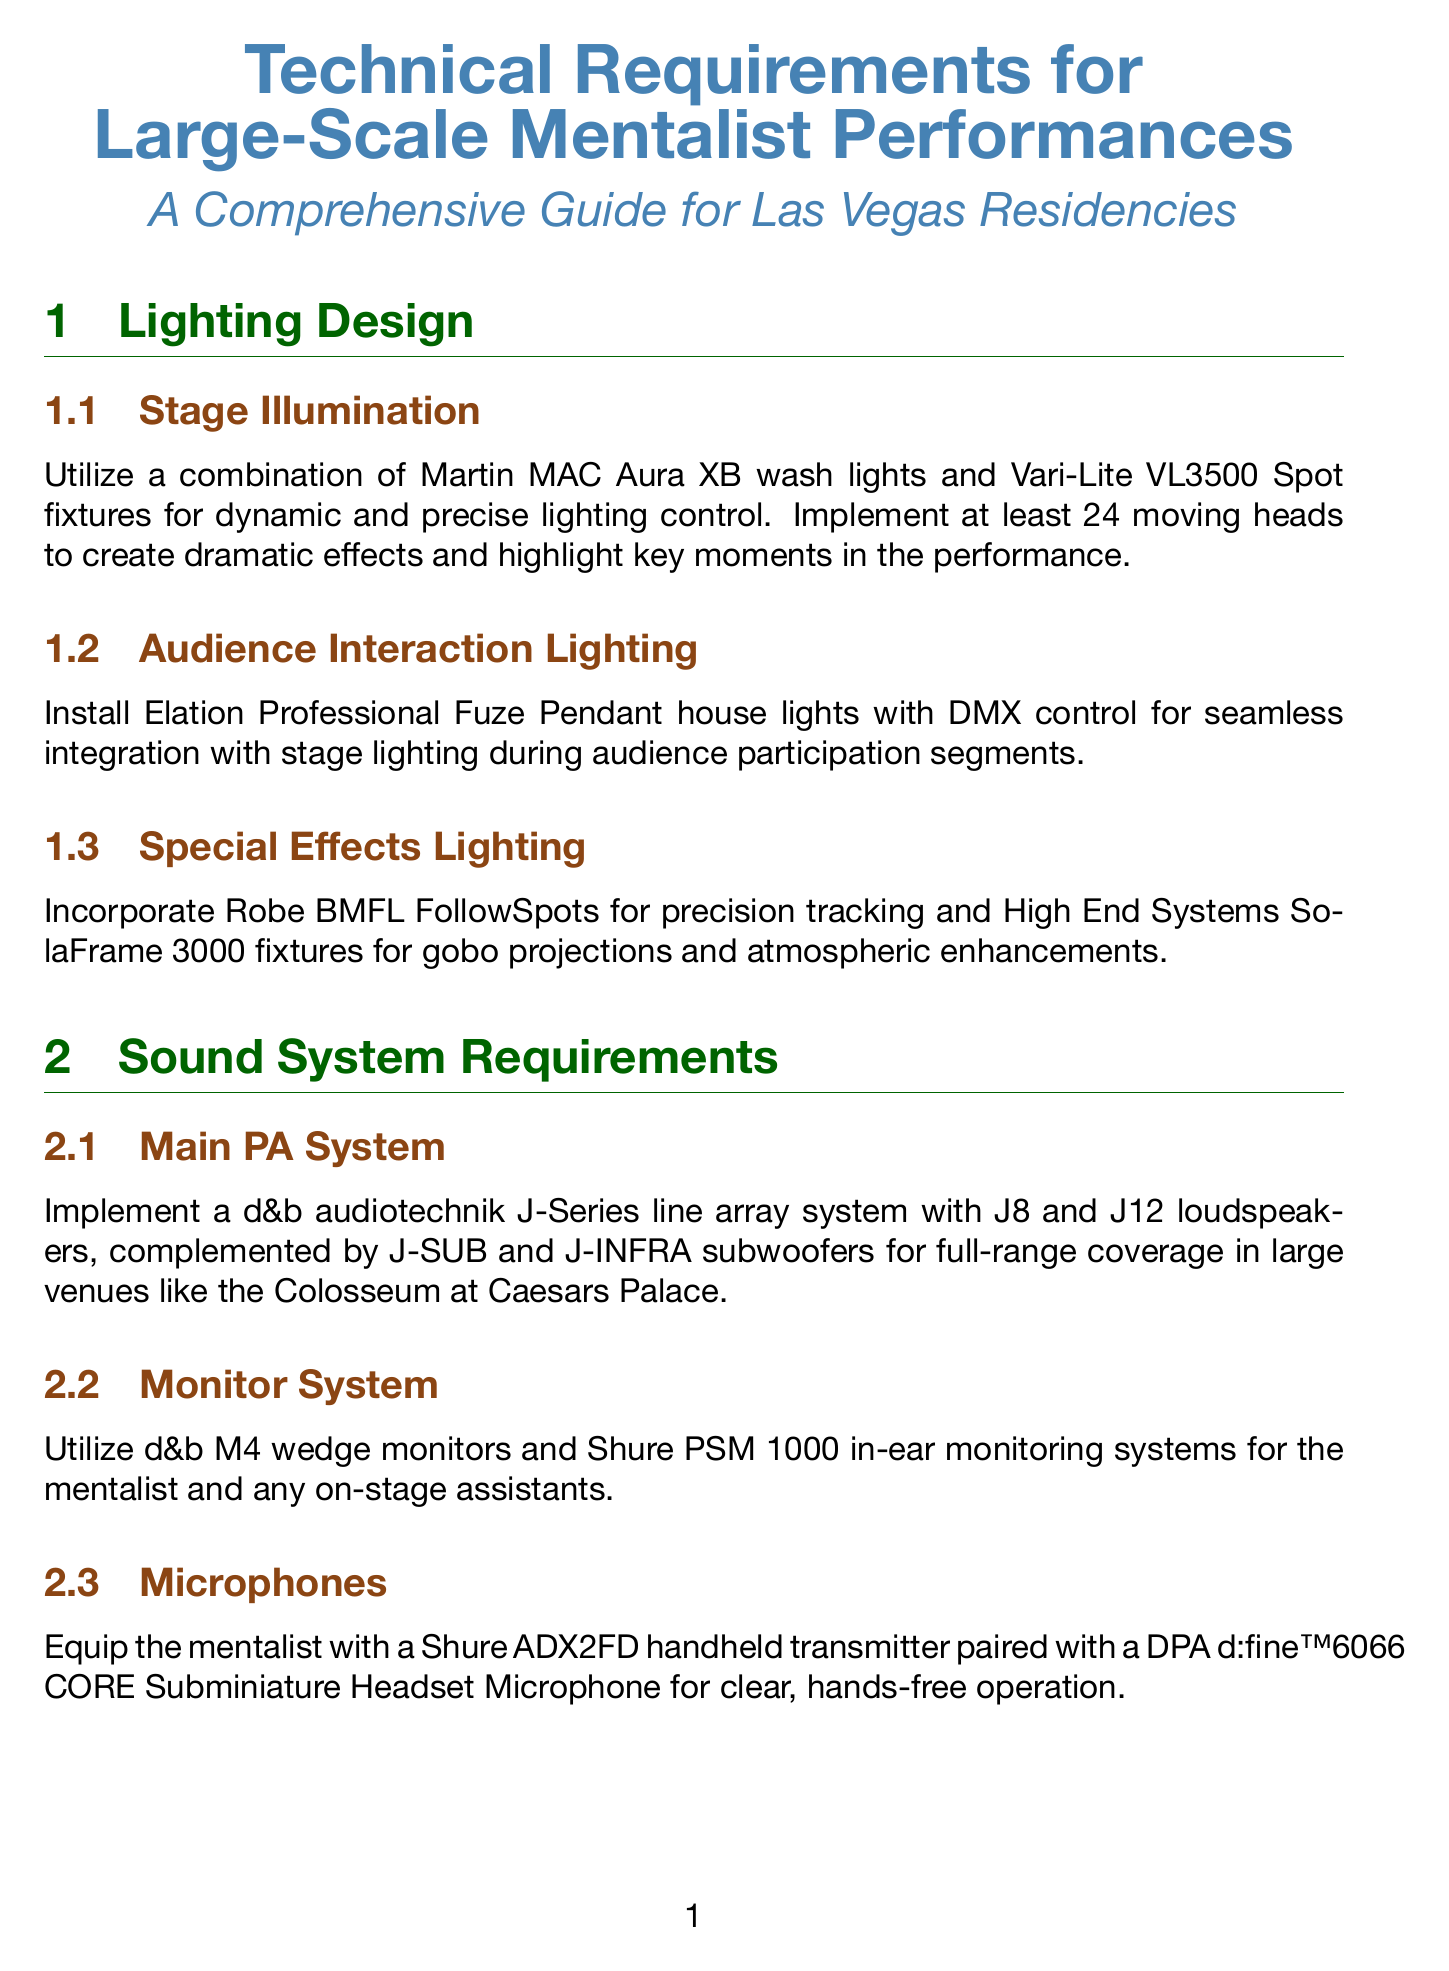What lighting fixtures are recommended for stage illumination? The document specifies using Martin MAC Aura XB wash lights and Vari-Lite VL3500 Spot fixtures for stage illumination.
Answer: Martin MAC Aura XB wash lights and Vari-Lite VL3500 Spot fixtures How many moving heads should be implemented? The manual suggests implementing at least 24 moving heads for dramatic effects.
Answer: 24 What sound system is recommended for large venues? The main PA system recommended is a d&b audiotechnik J-Series line array system.
Answer: d&b audiotechnik J-Series line array system What type of video projection system is suggested? A Barco UDX-4K32 laser projector is suggested for high-resolution backdrop projections.
Answer: Barco UDX-4K32 laser projector What safety standards should rigging comply with? The document states that all overhead rigging should comply with ANSI E1.21-2013 standards.
Answer: ANSI E1.21-2013 Which system is used for show control? The show control system recommended is Medialon Overture.
Answer: Medialon Overture What does the manual suggest for audience interaction lighting? The manual suggests installing Elation Professional Fuze Pendant house lights for audience interaction lighting.
Answer: Elation Professional Fuze Pendant house lights What type of haze generators are recommended? MDG ATMe haze generators are recommended for atmospheric effects.
Answer: MDG ATMe haze generators Which wireless intercom system is mentioned for communication? The Clear-Com FreeSpeak II wireless intercom system is mentioned for communication.
Answer: Clear-Com FreeSpeak II 